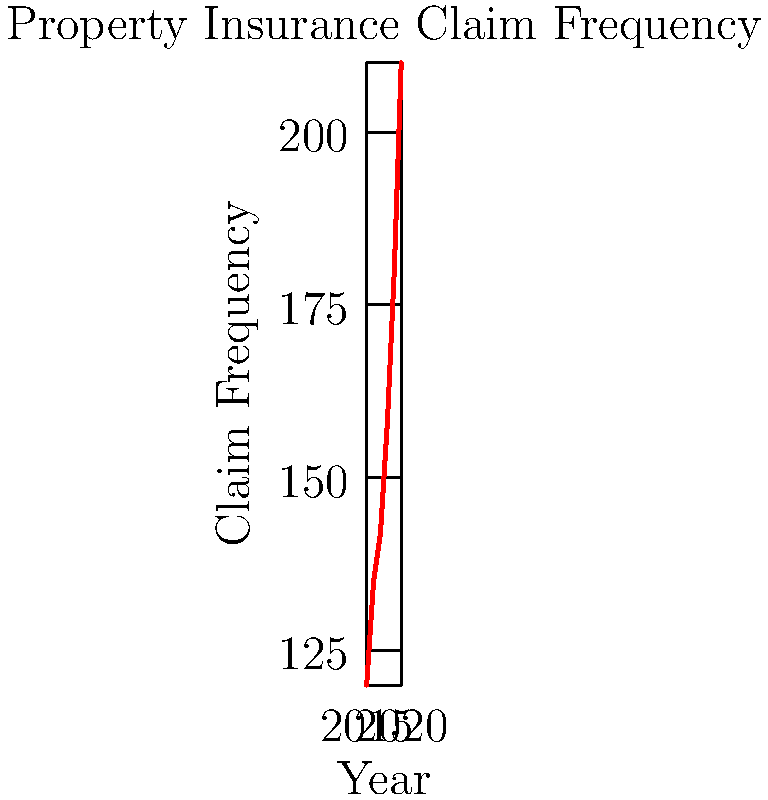Based on the time series plot of property insurance claim frequency from 2015 to 2020, calculate the average year-over-year percentage increase in claim frequency. Round your answer to the nearest whole percent. To solve this problem, we'll follow these steps:

1. Calculate the year-over-year percentage change for each year from 2016 to 2020.
2. Take the average of these percentage changes.
3. Round to the nearest whole percent.

Step 1: Calculate year-over-year percentage changes

2015 to 2016: $\frac{135 - 120}{120} \times 100\% = 12.5\%$
2016 to 2017: $\frac{142 - 135}{135} \times 100\% = 5.19\%$
2017 to 2018: $\frac{158 - 142}{142} \times 100\% = 11.27\%$
2018 to 2019: $\frac{180 - 158}{158} \times 100\% = 13.92\%$
2019 to 2020: $\frac{210 - 180}{180} \times 100\% = 16.67\%$

Step 2: Calculate the average

Average = $\frac{12.5\% + 5.19\% + 11.27\% + 13.92\% + 16.67\%}{5} = 11.91\%$

Step 3: Round to the nearest whole percent

11.91% rounds to 12%
Answer: 12% 